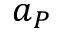Convert formula to latex. <formula><loc_0><loc_0><loc_500><loc_500>a _ { P }</formula> 